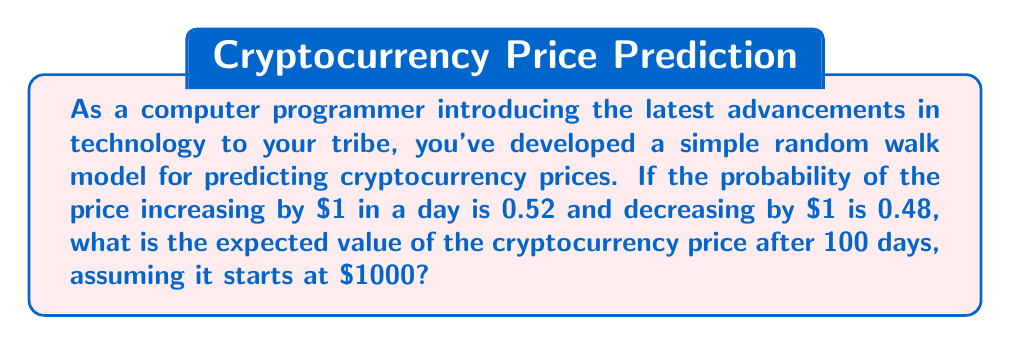Show me your answer to this math problem. Let's approach this step-by-step:

1) In a random walk model, the expected change in each step is calculated as:

   $E[\Delta X] = p \cdot \text{up movement} + (1-p) \cdot \text{down movement}$

   Where $p$ is the probability of an up movement.

2) In this case:
   $p = 0.52$
   up movement = $+$1
   down movement = $-$1

3) Plugging these values into the formula:

   $E[\Delta X] = 0.52 \cdot (+1) + 0.48 \cdot (-1) = 0.52 - 0.48 = 0.04$

4) This means that on average, we expect the price to increase by $0.04 each day.

5) Over 100 days, the expected total change would be:

   $100 \cdot E[\Delta X] = 100 \cdot 0.04 = 4$

6) Since the starting price is $1000, the expected price after 100 days would be:

   $1000 + 4 = 1004$

Therefore, the expected value of the cryptocurrency price after 100 days is $1004.
Answer: $1004 